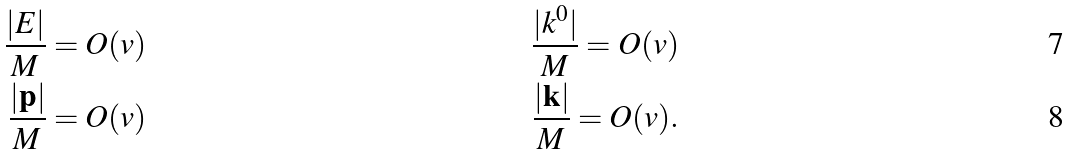Convert formula to latex. <formula><loc_0><loc_0><loc_500><loc_500>\frac { | E | } { M } & = O ( v ) & \frac { | k ^ { 0 } | } { M } = O ( v ) \\ \frac { | \mathbf p | } { M } & = O ( v ) & \frac { | \mathbf k | } { M } = O ( v ) .</formula> 